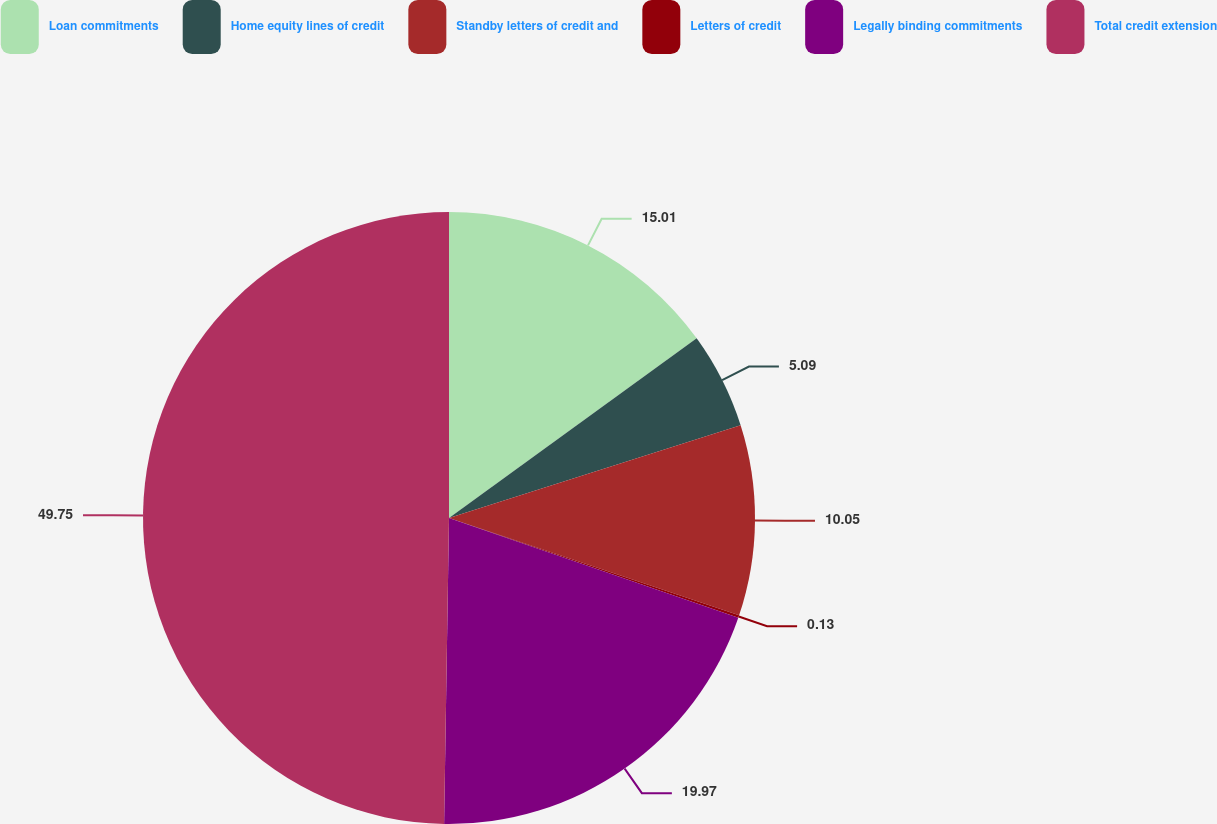Convert chart. <chart><loc_0><loc_0><loc_500><loc_500><pie_chart><fcel>Loan commitments<fcel>Home equity lines of credit<fcel>Standby letters of credit and<fcel>Letters of credit<fcel>Legally binding commitments<fcel>Total credit extension<nl><fcel>15.01%<fcel>5.09%<fcel>10.05%<fcel>0.13%<fcel>19.97%<fcel>49.74%<nl></chart> 